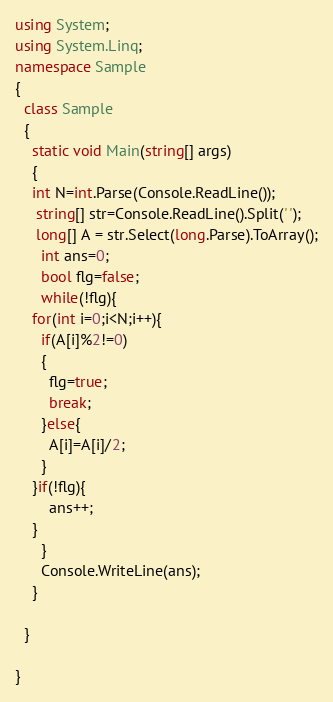Convert code to text. <code><loc_0><loc_0><loc_500><loc_500><_C#_>using System;
using System.Linq;
namespace Sample
{
  class Sample
  {
    static void Main(string[] args)
    {
    int N=int.Parse(Console.ReadLine());
     string[] str=Console.ReadLine().Split(' ');
     long[] A = str.Select(long.Parse).ToArray();
      int ans=0;
      bool flg=false;
      while(!flg){
    for(int i=0;i<N;i++){
      if(A[i]%2!=0)
      {
        flg=true;
        break;
      }else{
        A[i]=A[i]/2;
      }
    }if(!flg){
        ans++;
    }
      }
      Console.WriteLine(ans);
    }
    
  }

}</code> 